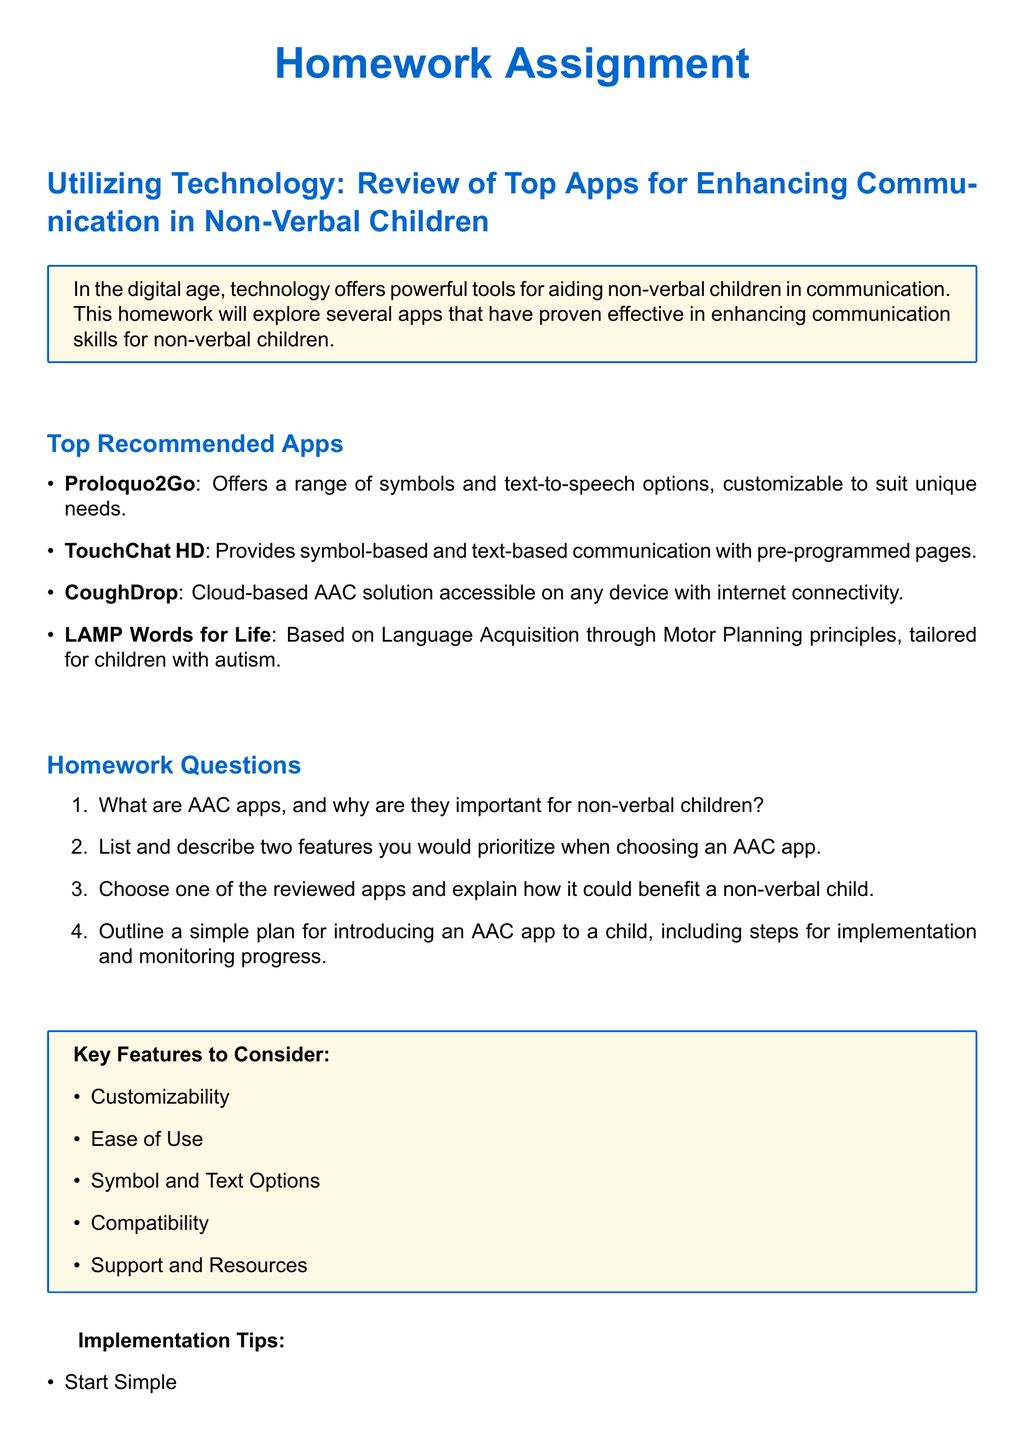What are AAC apps? AAC apps are tools used to aid communication for individuals who are non-verbal.
Answer: Tools for communication Name one of the reviewed apps. The document lists several apps; one example is Proloquo2Go.
Answer: Proloquo2Go What is a key feature of TouchChat HD? TouchChat HD provides symbol-based and text-based communication with pre-programmed pages.
Answer: Symbol-based communication How many recommended apps are listed in the document? The document lists four recommended apps.
Answer: Four What is the purpose of the implementation tips? Implementation tips help guide the introduction and use of the AAC app for communication improvement.
Answer: Guide introduction What principle does LAMP Words for Life utilize? LAMP Words for Life is based on Language Acquisition through Motor Planning principles.
Answer: Motor Planning principles What should be monitored regularly according to the document? The document suggests monitoring progress regularly when using the AAC app.
Answer: Progress List a feature to consider when choosing an AAC app. One feature to consider is customizability.
Answer: Customizability 